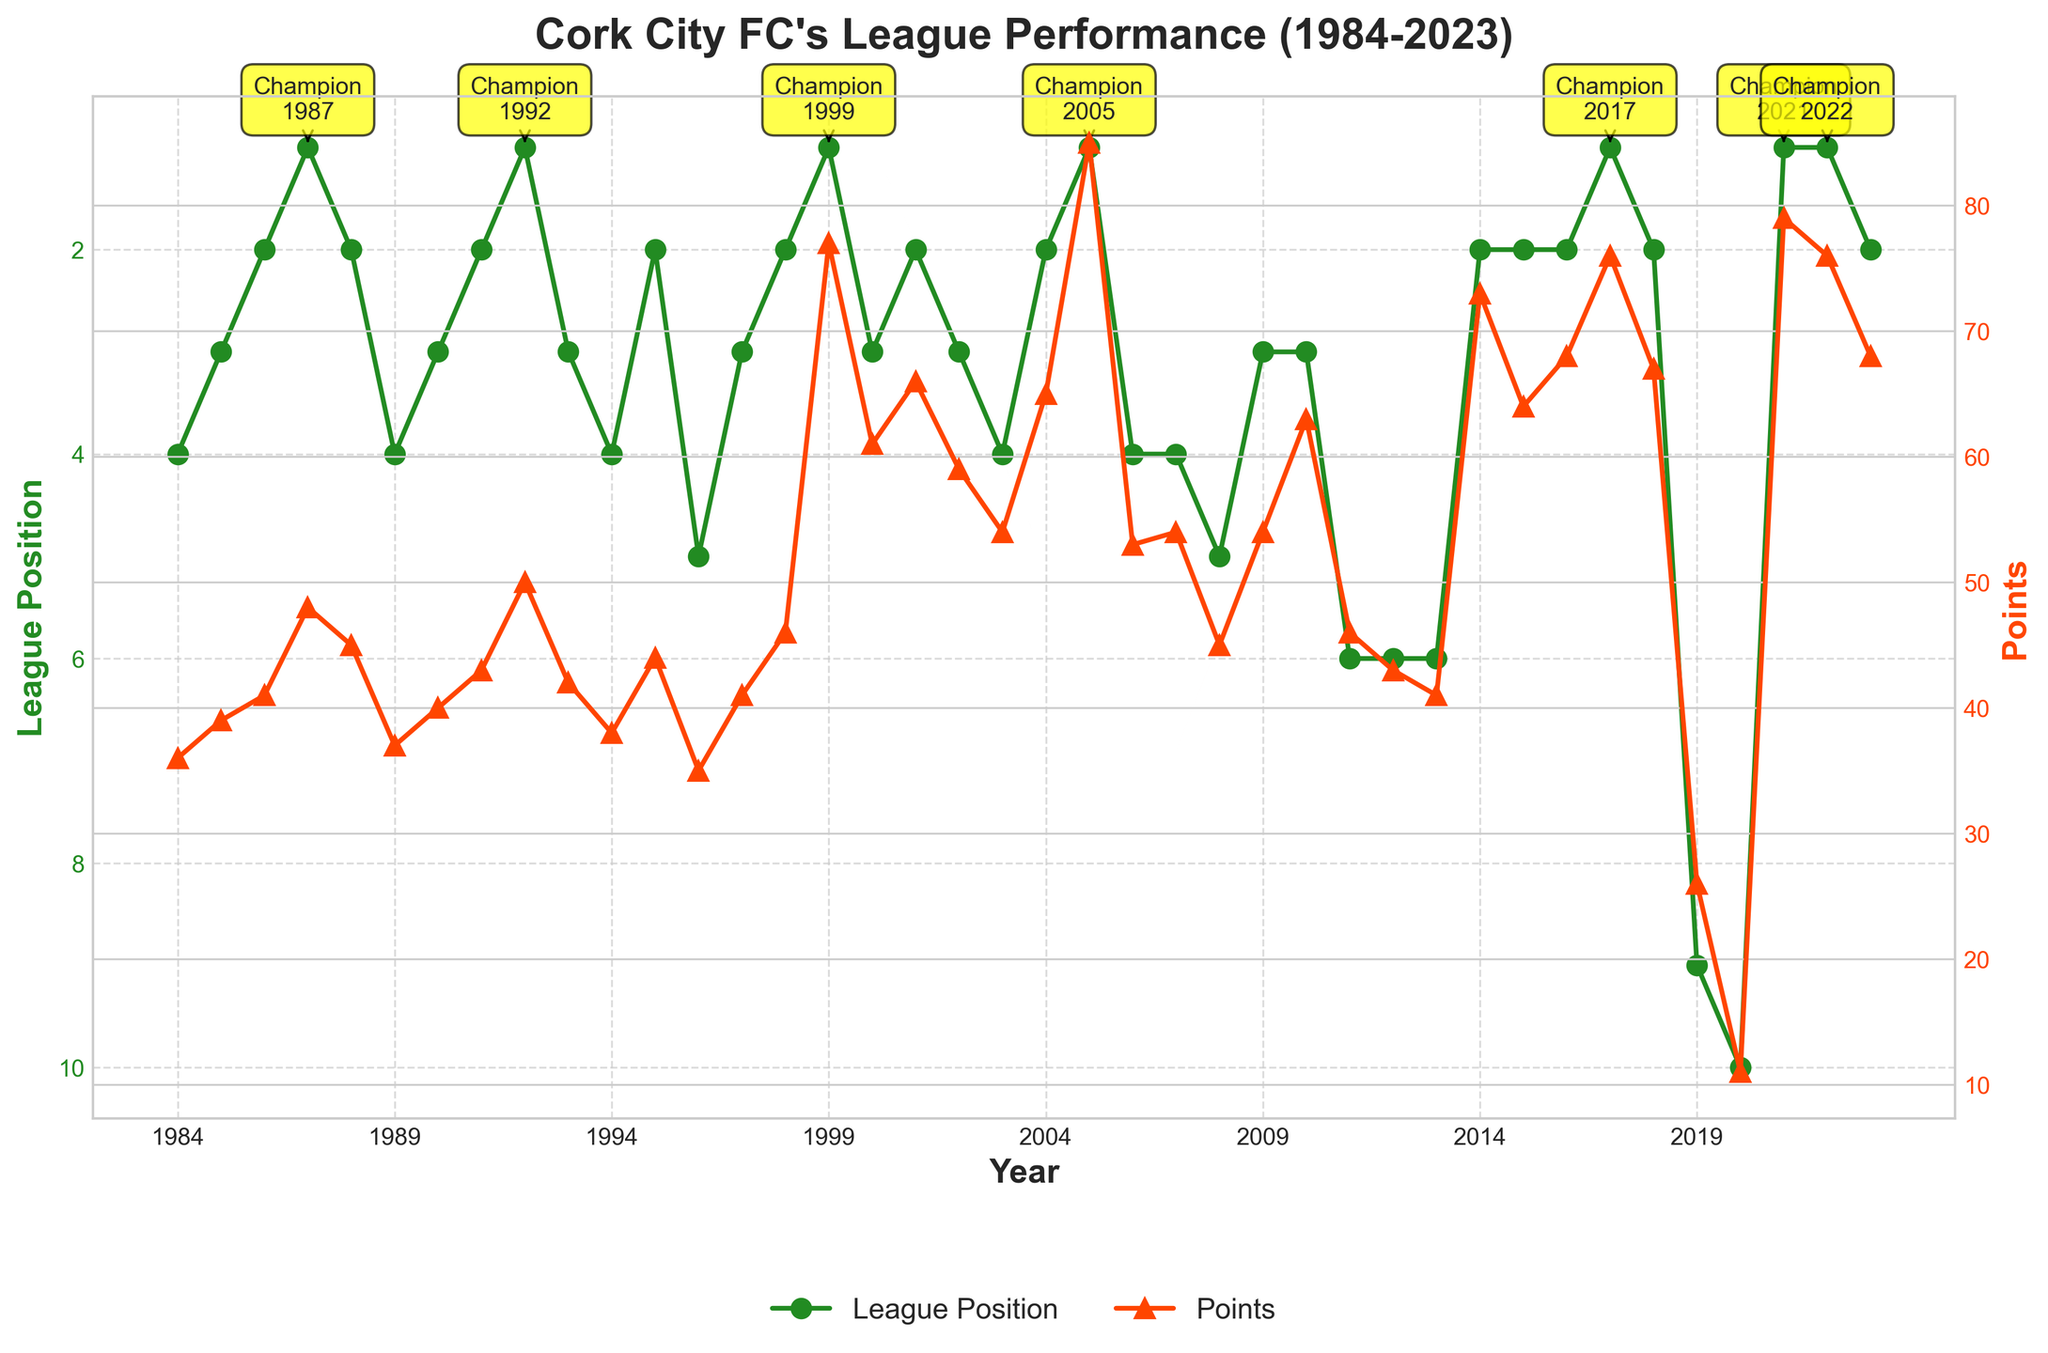What are the years Cork City FC won the league title? Identify the years where the label "Champion" appears on the plot. The annotations pinpoint the championship years.
Answer: 1987, 1992, 1999, 2005, 2017, 2021, 2022 What is the highest points total achieved, and in which year? Look at the second y-axis marked with red points and identify the peak value. It's observed that Cork City FC scored 85 points in the year 2005.
Answer: 85, 2005 In which year did Cork City FC achieve the lowest points total, and how many points did they score? Examine the red points on the right y-axis and find the minimum. Cork City FC scored 11 points in 2020, which is the lowest.
Answer: 11, 2020 How did the team's league position in 2017 compare to its position in 2018? Refer to the green line for the years 2017 and 2018. Cork City FC's league position was 1st in 2017 and 2nd in 2018.
Answer: 1st in 2017, 2nd in 2018 How many years did Cork City FC finish in the top 3? Count the number of years where the league position (green line) is 1, 2, or 3. From the plot, it's 21 years.
Answer: 21 What is the most common league position for Cork City FC based on the graph? Look at the green line and count the frequency of each league position. The 2nd position is observed most often, appearing about 11 times.
Answer: 2nd Between which consecutive years did Cork City FC experience the largest drop in points? Look at the red line and compare the differences between consecutive points values. The largest drop is from 2018 (67 points) to 2019 (26 points) which is a drop of 41 points.
Answer: 2018 to 2019 What was the average points total for Cork City FC during the years they finished 1st? Identify the points corresponding to the years 1987, 1992, 1999, 2005, 2017, 2021, 2022 (the years Cork City FC finished 1st). Sum those points and divide by the number of years. (48 + 50 + 77 + 85 + 76 + 79 + 76) / 7 = 70.14.
Answer: 70.14 